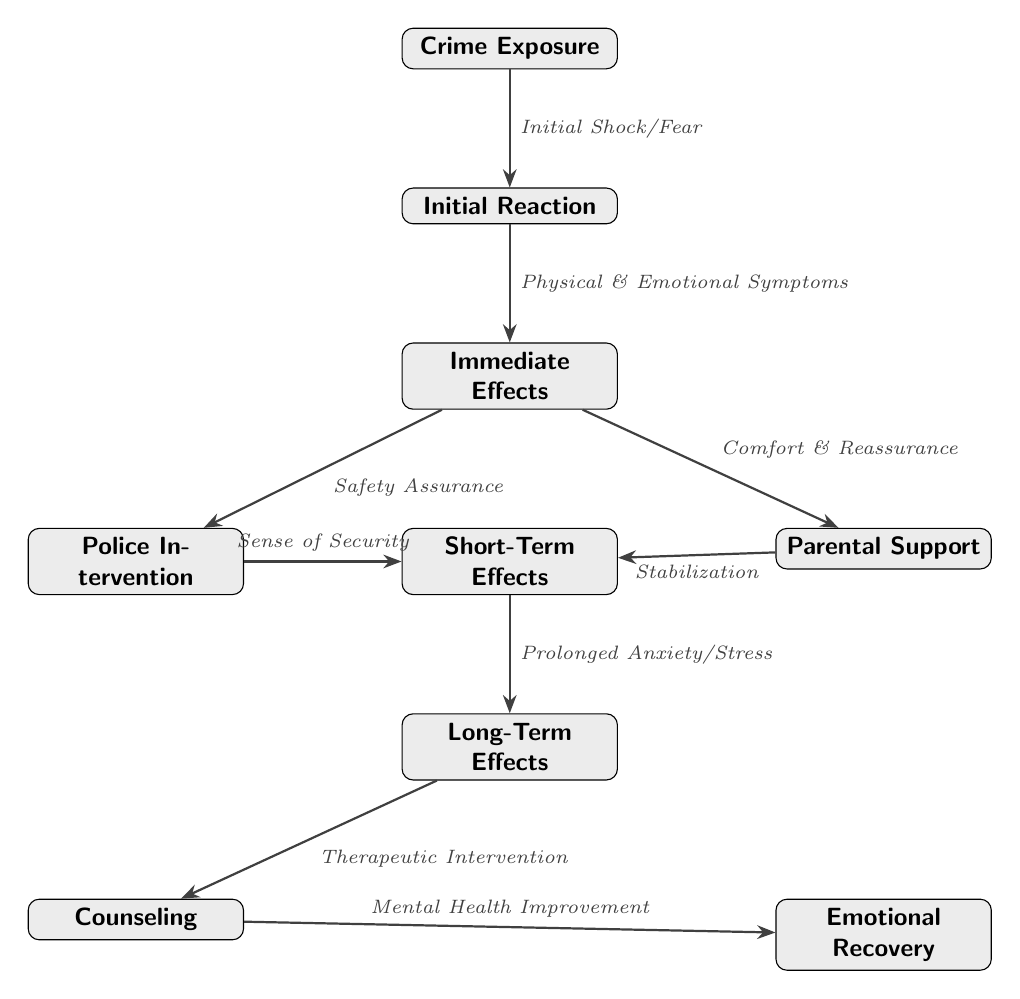What is the first stage after crime exposure? The first stage in the diagram after "Crime Exposure" is "Initial Reaction." This is indicated by the direct flow from the "Crime Exposure" node to the "Initial Reaction" node.
Answer: Initial Reaction How many intervention points are indicated in the diagram? There are two intervention points: "Police Intervention" and "Parental Support." These points are indicated by the branches stemming from "Immediate Effects."
Answer: 2 What connects "Immediate Effects" to "Short-Term Effects"? The connection from "Immediate Effects" to "Short-Term Effects" is through both "Safety Assurance" from "Police Intervention" and "Comfort & Reassurance" from "Parental Support." This shows that both interventions lead to "Short-Term Effects."
Answer: Safety Assurance, Comfort & Reassurance What are the two outcomes after "Long-Term Effects"? The two outcomes after "Long-Term Effects" are "Counseling" and "Emotional Recovery." These outcomes branch out from the "Long-Term Effects" node, showing potential paths to improvement.
Answer: Counseling, Emotional Recovery What is the emotional response directly following "Initial Reaction"? The emotional response that follows "Initial Reaction" is "Physical & Emotional Symptoms." This is the next stage in the sequence shown in the diagram, immediately leading from "Initial Reaction."
Answer: Physical & Emotional Symptoms What leads to "Mental Health Improvement"? "Mental Health Improvement" leads from "Therapeutic Intervention," which is connected to "Counseling." The flow indicates that therapeutic measures are taken to enhance mental health subsequently.
Answer: Counseling What is the main effect following "Short-Term Effects"? The main effect following "Short-Term Effects" is "Prolonged Anxiety/Stress." This indicates how initial effects can develop into longer-term psychological issues.
Answer: Prolonged Anxiety/Stress Which node suggests a form of support provided by parents? "Parental Support" suggests a form of support provided by parents. It is a distinct node that represents their role in helping children after exposure to crime.
Answer: Parental Support 